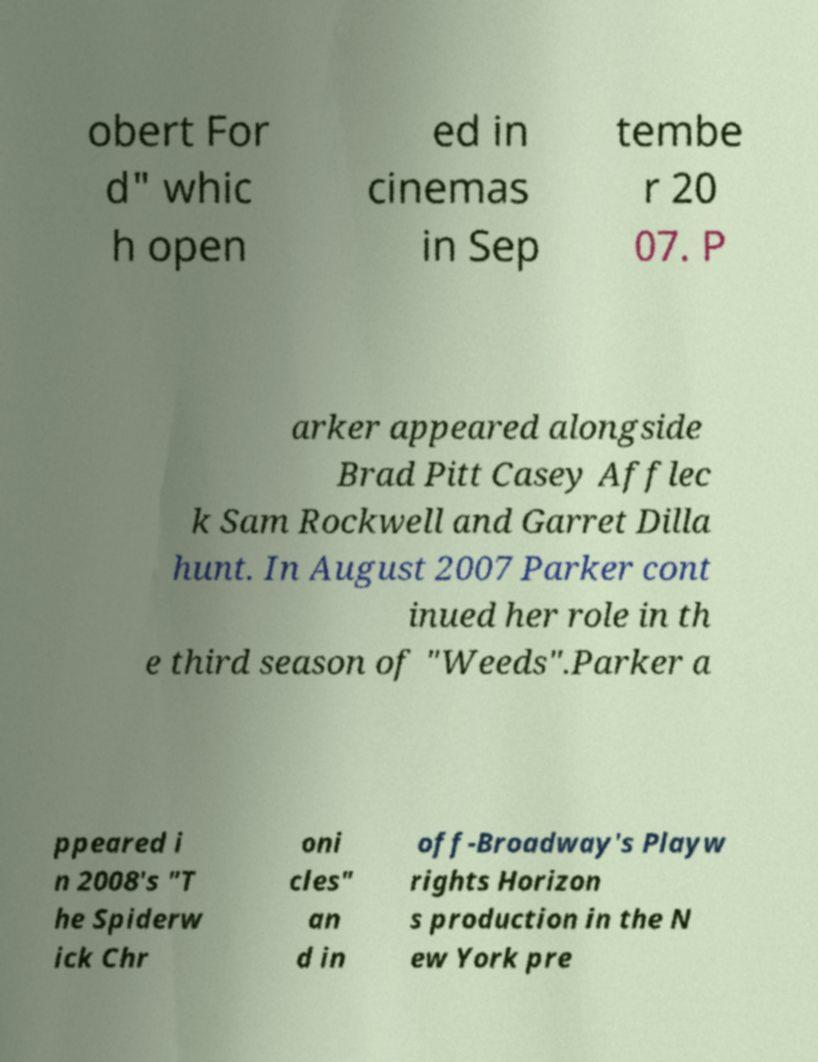Can you read and provide the text displayed in the image?This photo seems to have some interesting text. Can you extract and type it out for me? obert For d" whic h open ed in cinemas in Sep tembe r 20 07. P arker appeared alongside Brad Pitt Casey Afflec k Sam Rockwell and Garret Dilla hunt. In August 2007 Parker cont inued her role in th e third season of "Weeds".Parker a ppeared i n 2008's "T he Spiderw ick Chr oni cles" an d in off-Broadway's Playw rights Horizon s production in the N ew York pre 